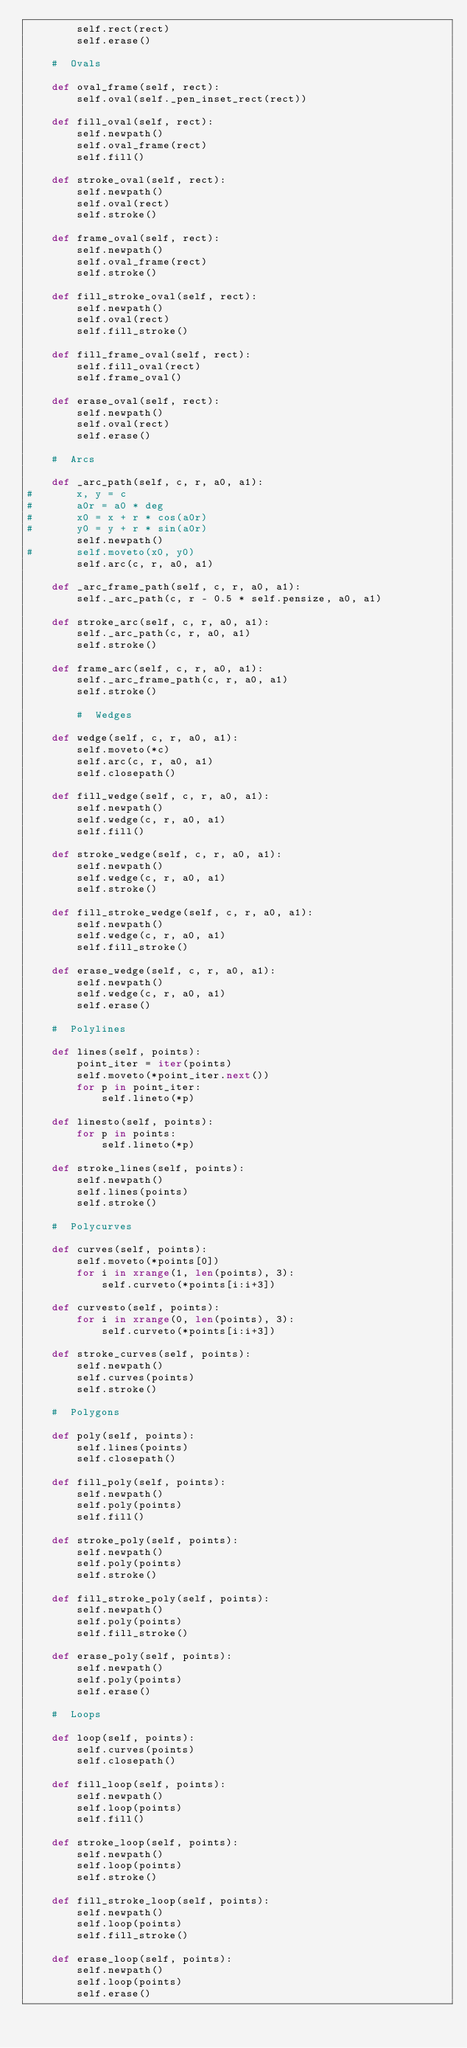<code> <loc_0><loc_0><loc_500><loc_500><_Python_>		self.rect(rect)
		self.erase()
	
	#  Ovals
	
	def oval_frame(self, rect):
		self.oval(self._pen_inset_rect(rect))
	
	def fill_oval(self, rect):
		self.newpath()
		self.oval_frame(rect)
		self.fill()
	
	def stroke_oval(self, rect):
		self.newpath()
		self.oval(rect)
		self.stroke()
	
	def frame_oval(self, rect):
		self.newpath()
		self.oval_frame(rect)
		self.stroke()

	def fill_stroke_oval(self, rect):
		self.newpath()
		self.oval(rect)
		self.fill_stroke()

	def fill_frame_oval(self, rect):
		self.fill_oval(rect)
		self.frame_oval()

	def erase_oval(self, rect):
		self.newpath()
		self.oval(rect)
		self.erase()
	
	#  Arcs
	
	def _arc_path(self, c, r, a0, a1):
#		x, y = c
#		a0r = a0 * deg
#		x0 = x + r * cos(a0r)
#		y0 = y + r * sin(a0r)
		self.newpath()
#		self.moveto(x0, y0)
		self.arc(c, r, a0, a1)
	
	def _arc_frame_path(self, c, r, a0, a1):
		self._arc_path(c, r - 0.5 * self.pensize, a0, a1)
	
	def stroke_arc(self, c, r, a0, a1):
		self._arc_path(c, r, a0, a1)
		self.stroke()
	
	def frame_arc(self, c, r, a0, a1):
		self._arc_frame_path(c, r, a0, a1)
		self.stroke()
	
		#  Wedges
	
	def wedge(self, c, r, a0, a1):
		self.moveto(*c)
		self.arc(c, r, a0, a1)
		self.closepath()
	
	def fill_wedge(self, c, r, a0, a1):
		self.newpath()
		self.wedge(c, r, a0, a1)
		self.fill()
	
	def stroke_wedge(self, c, r, a0, a1):
		self.newpath()
		self.wedge(c, r, a0, a1)
		self.stroke()
	
	def fill_stroke_wedge(self, c, r, a0, a1):
		self.newpath()
		self.wedge(c, r, a0, a1)
		self.fill_stroke()
	
	def erase_wedge(self, c, r, a0, a1):
		self.newpath()
		self.wedge(c, r, a0, a1)
		self.erase()
	
	#  Polylines
	
	def lines(self, points):
		point_iter = iter(points)
		self.moveto(*point_iter.next())
		for p in point_iter:
			self.lineto(*p)
	
	def linesto(self, points):
		for p in points:
			self.lineto(*p)
	
	def stroke_lines(self, points):
		self.newpath()
		self.lines(points)
		self.stroke()
	
	#  Polycurves
	
	def curves(self, points):
		self.moveto(*points[0])
		for i in xrange(1, len(points), 3):
			self.curveto(*points[i:i+3])
	
	def curvesto(self, points):
		for i in xrange(0, len(points), 3):
			self.curveto(*points[i:i+3])
				
	def stroke_curves(self, points):
		self.newpath()
		self.curves(points)
		self.stroke()
				
	#  Polygons

	def poly(self, points):
		self.lines(points)
		self.closepath()
		
	def fill_poly(self, points):
		self.newpath()
		self.poly(points)
		self.fill()
	
	def stroke_poly(self, points):
		self.newpath()
		self.poly(points)
		self.stroke()
	
	def fill_stroke_poly(self, points):
		self.newpath()
		self.poly(points)
		self.fill_stroke()

	def erase_poly(self, points):
		self.newpath()
		self.poly(points)
		self.erase()

	#  Loops
	
	def loop(self, points):
		self.curves(points)
		self.closepath()
	
	def fill_loop(self, points):
		self.newpath()
		self.loop(points)
		self.fill()
	
	def stroke_loop(self, points):
		self.newpath()
		self.loop(points)
		self.stroke()
	
	def fill_stroke_loop(self, points):
		self.newpath()
		self.loop(points)
		self.fill_stroke()

	def erase_loop(self, points):
		self.newpath()
		self.loop(points)
		self.erase()
</code> 